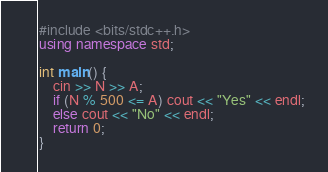<code> <loc_0><loc_0><loc_500><loc_500><_C++_>#include <bits/stdc++.h>
using namespace std;
 
int main() {
	cin >> N >> A;
	if (N % 500 <= A) cout << "Yes" << endl;
	else cout << "No" << endl;
	return 0;
}</code> 